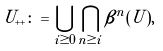<formula> <loc_0><loc_0><loc_500><loc_500>U _ { + + } \colon = \bigcup _ { i \geq 0 } \bigcap _ { n \geq i } \beta ^ { n } ( U ) ,</formula> 